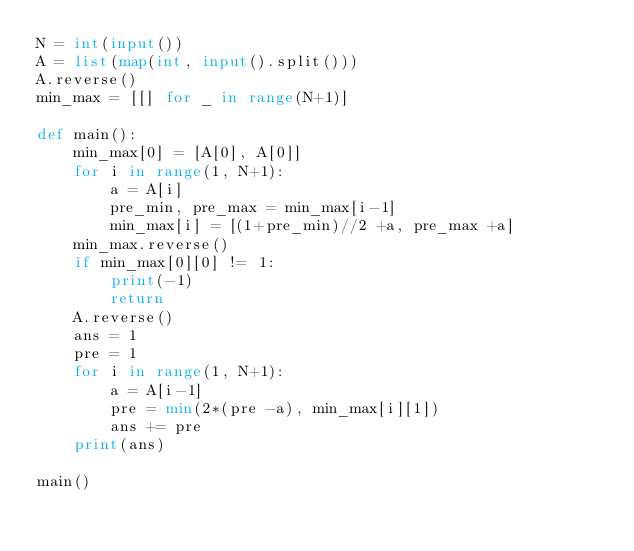Convert code to text. <code><loc_0><loc_0><loc_500><loc_500><_Python_>N = int(input())
A = list(map(int, input().split()))
A.reverse()
min_max = [[] for _ in range(N+1)]

def main():
    min_max[0] = [A[0], A[0]]
    for i in range(1, N+1):
        a = A[i]
        pre_min, pre_max = min_max[i-1]
        min_max[i] = [(1+pre_min)//2 +a, pre_max +a]
    min_max.reverse()
    if min_max[0][0] != 1:
        print(-1)
        return
    A.reverse()
    ans = 1
    pre = 1
    for i in range(1, N+1):
        a = A[i-1]
        pre = min(2*(pre -a), min_max[i][1])
        ans += pre
    print(ans)

main()</code> 